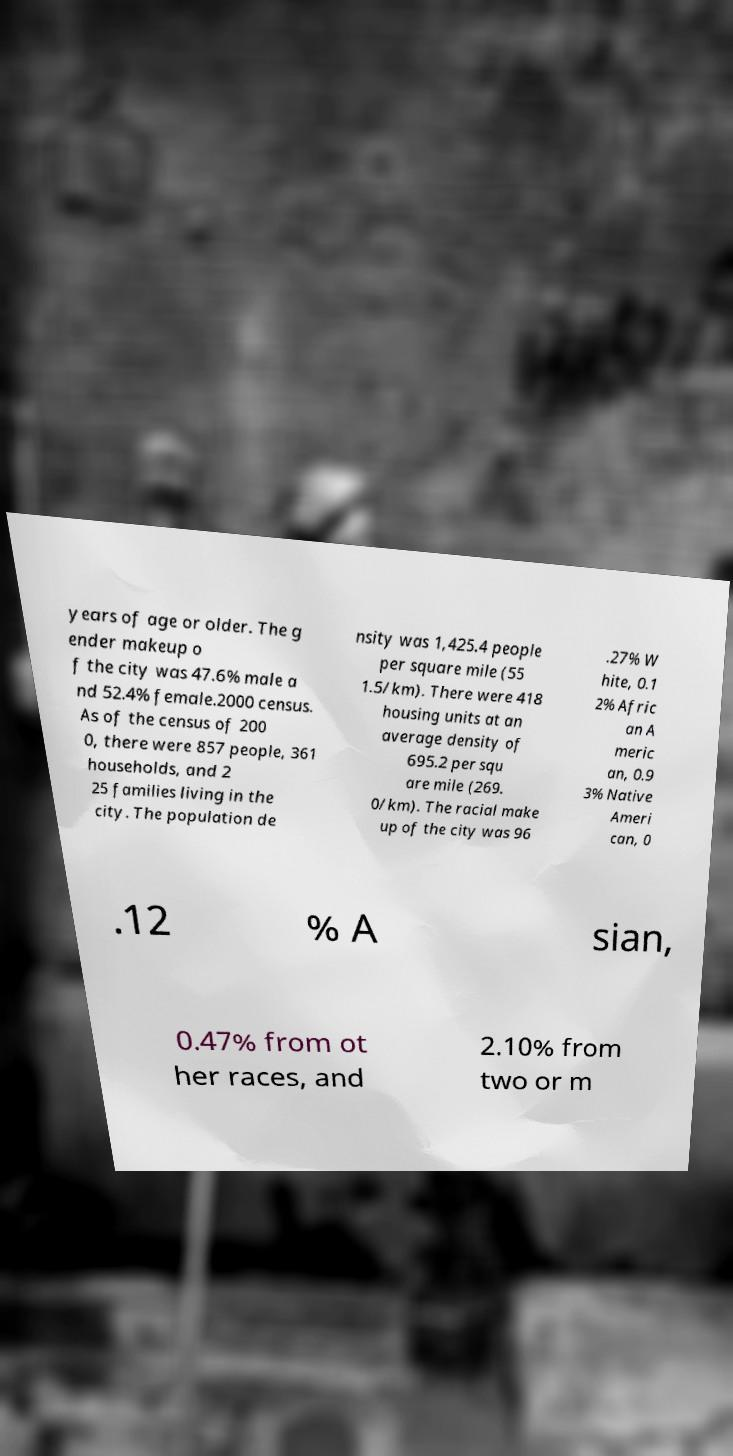Could you extract and type out the text from this image? years of age or older. The g ender makeup o f the city was 47.6% male a nd 52.4% female.2000 census. As of the census of 200 0, there were 857 people, 361 households, and 2 25 families living in the city. The population de nsity was 1,425.4 people per square mile (55 1.5/km). There were 418 housing units at an average density of 695.2 per squ are mile (269. 0/km). The racial make up of the city was 96 .27% W hite, 0.1 2% Afric an A meric an, 0.9 3% Native Ameri can, 0 .12 % A sian, 0.47% from ot her races, and 2.10% from two or m 